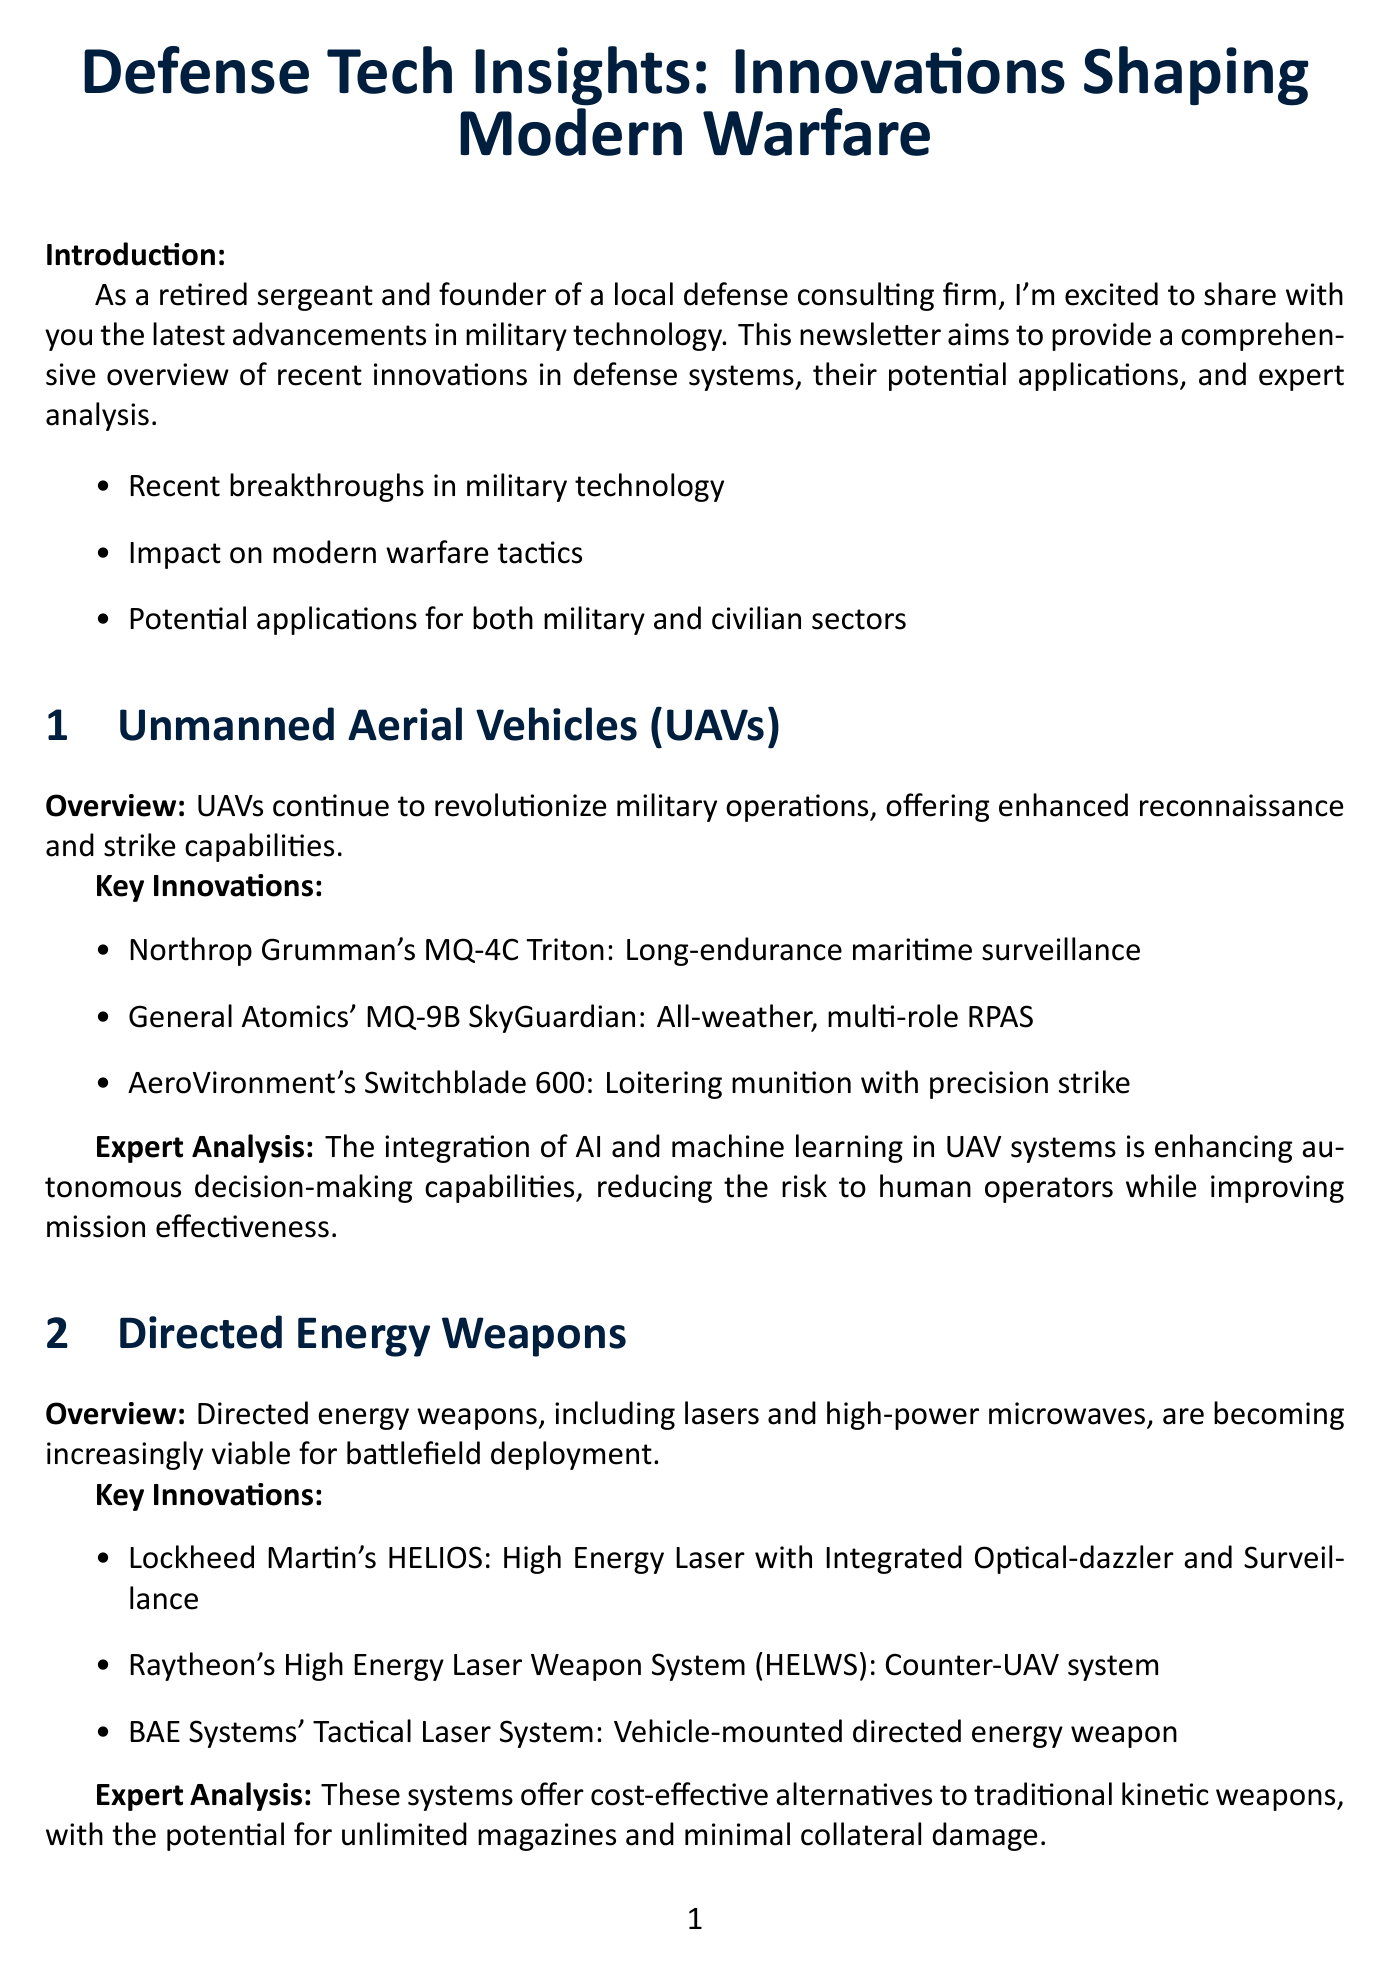What is the title of the newsletter? The title of the newsletter is stated at the beginning of the document as "Defense Tech Insights: Innovations Shaping Modern Warfare."
Answer: Defense Tech Insights: Innovations Shaping Modern Warfare Who is the author of the newsletter? The author is introduced in the "About the Author" section, detailing his name and credentials.
Answer: John Smith What is one of the key innovations in UAVs? The document lists several key innovations in the UAV section, highlighting one example.
Answer: Northrop Grumman's MQ-4C Triton What type of weapon system is HELIOS? The document specifies HELIOS in the directed energy weapons section as a specific type of weapon system.
Answer: High Energy Laser What is one application of military drone technology in civilian sectors? The document refers to the application of military drone technology as used in agriculture, search and rescue, or delivery services.
Answer: Delivery services What technology did Amazon adapt for drone delivery services? The case study section mentions this specific technology developed for military use.
Answer: Sense-and-avoid technology What has improved soldier protection according to recent advancements? The information in the document states that material science and robotics have contributed to enhanced protection.
Answer: Body Armor and Exoskeletons What is the significance of the integration of AI in UAV systems? The expert analysis explains the impact of AI integration on UAV systems regarding decision-making.
Answer: Enhancing autonomous decision-making capabilities 